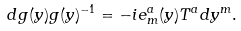Convert formula to latex. <formula><loc_0><loc_0><loc_500><loc_500>d g ( y ) g ( y ) ^ { - 1 } = - i e ^ { a } _ { m } ( y ) T ^ { a } d y ^ { m } .</formula> 